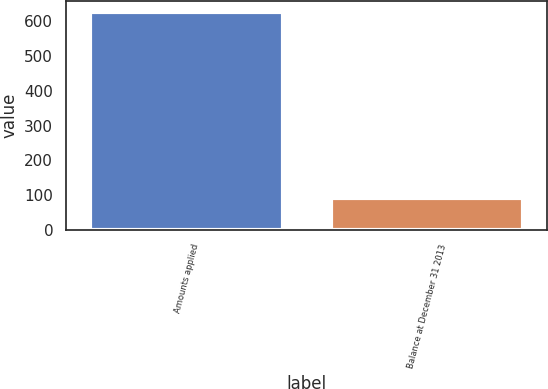Convert chart. <chart><loc_0><loc_0><loc_500><loc_500><bar_chart><fcel>Amounts applied<fcel>Balance at December 31 2013<nl><fcel>626<fcel>92<nl></chart> 